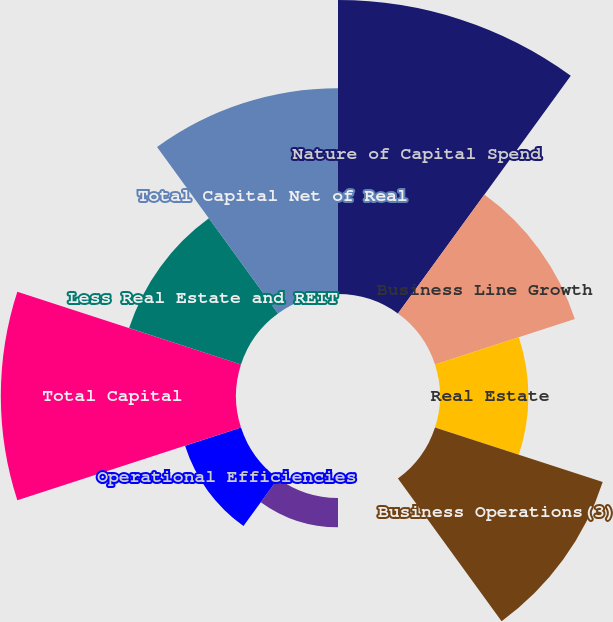<chart> <loc_0><loc_0><loc_500><loc_500><pie_chart><fcel>Nature of Capital Spend<fcel>Business Line Growth<fcel>Real Estate<fcel>Business Operations(3)<fcel>Product Development<fcel>Product Improvement<fcel>Operational Efficiencies<fcel>Total Capital<fcel>Less Real Estate and REIT<fcel>Total Capital Net of Real<nl><fcel>21.74%<fcel>10.87%<fcel>6.52%<fcel>13.04%<fcel>0.0%<fcel>2.17%<fcel>4.35%<fcel>17.39%<fcel>8.7%<fcel>15.22%<nl></chart> 